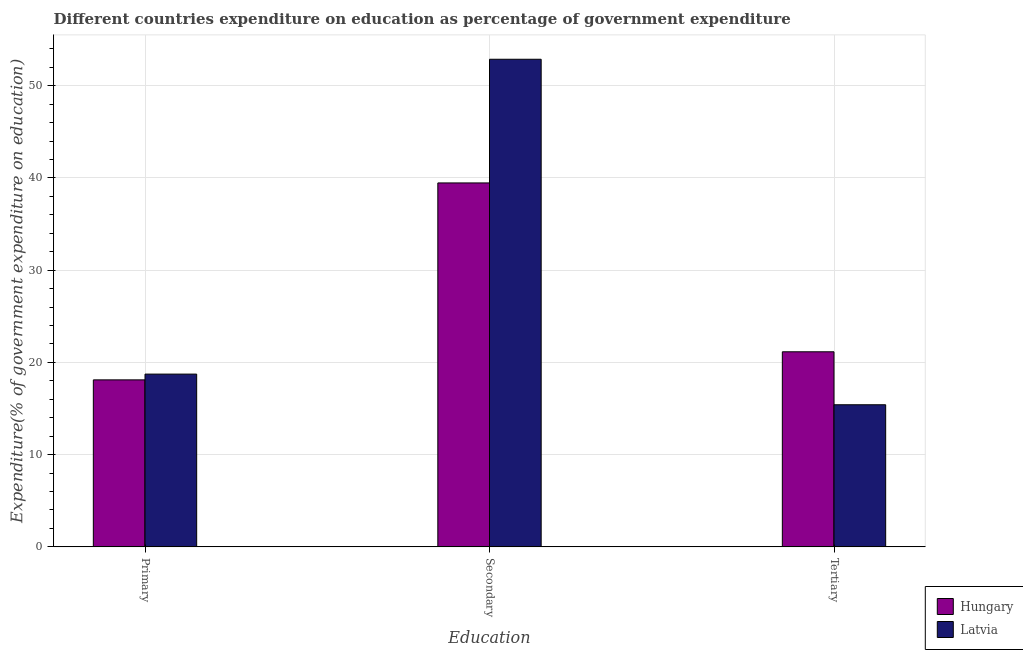Are the number of bars per tick equal to the number of legend labels?
Offer a terse response. Yes. Are the number of bars on each tick of the X-axis equal?
Your response must be concise. Yes. How many bars are there on the 1st tick from the left?
Provide a short and direct response. 2. How many bars are there on the 3rd tick from the right?
Provide a succinct answer. 2. What is the label of the 1st group of bars from the left?
Your answer should be very brief. Primary. What is the expenditure on primary education in Latvia?
Your answer should be very brief. 18.73. Across all countries, what is the maximum expenditure on tertiary education?
Ensure brevity in your answer.  21.15. Across all countries, what is the minimum expenditure on tertiary education?
Ensure brevity in your answer.  15.41. In which country was the expenditure on tertiary education maximum?
Your answer should be compact. Hungary. In which country was the expenditure on primary education minimum?
Make the answer very short. Hungary. What is the total expenditure on secondary education in the graph?
Provide a succinct answer. 92.33. What is the difference between the expenditure on primary education in Latvia and that in Hungary?
Your answer should be compact. 0.62. What is the difference between the expenditure on secondary education in Latvia and the expenditure on primary education in Hungary?
Your response must be concise. 34.76. What is the average expenditure on primary education per country?
Give a very brief answer. 18.42. What is the difference between the expenditure on primary education and expenditure on secondary education in Hungary?
Keep it short and to the point. -21.35. What is the ratio of the expenditure on primary education in Hungary to that in Latvia?
Keep it short and to the point. 0.97. What is the difference between the highest and the second highest expenditure on tertiary education?
Give a very brief answer. 5.74. What is the difference between the highest and the lowest expenditure on secondary education?
Keep it short and to the point. 13.41. What does the 1st bar from the left in Secondary represents?
Offer a terse response. Hungary. What does the 2nd bar from the right in Tertiary represents?
Keep it short and to the point. Hungary. Are all the bars in the graph horizontal?
Make the answer very short. No. Are the values on the major ticks of Y-axis written in scientific E-notation?
Offer a terse response. No. How many legend labels are there?
Provide a succinct answer. 2. How are the legend labels stacked?
Provide a succinct answer. Vertical. What is the title of the graph?
Ensure brevity in your answer.  Different countries expenditure on education as percentage of government expenditure. Does "Nepal" appear as one of the legend labels in the graph?
Your response must be concise. No. What is the label or title of the X-axis?
Your response must be concise. Education. What is the label or title of the Y-axis?
Your answer should be very brief. Expenditure(% of government expenditure on education). What is the Expenditure(% of government expenditure on education) in Hungary in Primary?
Ensure brevity in your answer.  18.11. What is the Expenditure(% of government expenditure on education) in Latvia in Primary?
Provide a succinct answer. 18.73. What is the Expenditure(% of government expenditure on education) in Hungary in Secondary?
Offer a terse response. 39.46. What is the Expenditure(% of government expenditure on education) in Latvia in Secondary?
Provide a succinct answer. 52.87. What is the Expenditure(% of government expenditure on education) of Hungary in Tertiary?
Your answer should be compact. 21.15. What is the Expenditure(% of government expenditure on education) of Latvia in Tertiary?
Provide a succinct answer. 15.41. Across all Education, what is the maximum Expenditure(% of government expenditure on education) of Hungary?
Ensure brevity in your answer.  39.46. Across all Education, what is the maximum Expenditure(% of government expenditure on education) in Latvia?
Keep it short and to the point. 52.87. Across all Education, what is the minimum Expenditure(% of government expenditure on education) of Hungary?
Your answer should be very brief. 18.11. Across all Education, what is the minimum Expenditure(% of government expenditure on education) of Latvia?
Offer a very short reply. 15.41. What is the total Expenditure(% of government expenditure on education) in Hungary in the graph?
Offer a terse response. 78.72. What is the total Expenditure(% of government expenditure on education) of Latvia in the graph?
Provide a short and direct response. 87.01. What is the difference between the Expenditure(% of government expenditure on education) in Hungary in Primary and that in Secondary?
Offer a terse response. -21.35. What is the difference between the Expenditure(% of government expenditure on education) of Latvia in Primary and that in Secondary?
Your answer should be very brief. -34.14. What is the difference between the Expenditure(% of government expenditure on education) of Hungary in Primary and that in Tertiary?
Make the answer very short. -3.04. What is the difference between the Expenditure(% of government expenditure on education) in Latvia in Primary and that in Tertiary?
Make the answer very short. 3.32. What is the difference between the Expenditure(% of government expenditure on education) of Hungary in Secondary and that in Tertiary?
Keep it short and to the point. 18.31. What is the difference between the Expenditure(% of government expenditure on education) of Latvia in Secondary and that in Tertiary?
Provide a short and direct response. 37.46. What is the difference between the Expenditure(% of government expenditure on education) of Hungary in Primary and the Expenditure(% of government expenditure on education) of Latvia in Secondary?
Your response must be concise. -34.76. What is the difference between the Expenditure(% of government expenditure on education) of Hungary in Primary and the Expenditure(% of government expenditure on education) of Latvia in Tertiary?
Offer a terse response. 2.7. What is the difference between the Expenditure(% of government expenditure on education) in Hungary in Secondary and the Expenditure(% of government expenditure on education) in Latvia in Tertiary?
Offer a terse response. 24.05. What is the average Expenditure(% of government expenditure on education) of Hungary per Education?
Give a very brief answer. 26.24. What is the average Expenditure(% of government expenditure on education) of Latvia per Education?
Your response must be concise. 29. What is the difference between the Expenditure(% of government expenditure on education) in Hungary and Expenditure(% of government expenditure on education) in Latvia in Primary?
Provide a succinct answer. -0.62. What is the difference between the Expenditure(% of government expenditure on education) of Hungary and Expenditure(% of government expenditure on education) of Latvia in Secondary?
Offer a very short reply. -13.41. What is the difference between the Expenditure(% of government expenditure on education) of Hungary and Expenditure(% of government expenditure on education) of Latvia in Tertiary?
Offer a terse response. 5.74. What is the ratio of the Expenditure(% of government expenditure on education) of Hungary in Primary to that in Secondary?
Ensure brevity in your answer.  0.46. What is the ratio of the Expenditure(% of government expenditure on education) in Latvia in Primary to that in Secondary?
Provide a short and direct response. 0.35. What is the ratio of the Expenditure(% of government expenditure on education) in Hungary in Primary to that in Tertiary?
Provide a succinct answer. 0.86. What is the ratio of the Expenditure(% of government expenditure on education) of Latvia in Primary to that in Tertiary?
Keep it short and to the point. 1.22. What is the ratio of the Expenditure(% of government expenditure on education) of Hungary in Secondary to that in Tertiary?
Ensure brevity in your answer.  1.87. What is the ratio of the Expenditure(% of government expenditure on education) of Latvia in Secondary to that in Tertiary?
Offer a very short reply. 3.43. What is the difference between the highest and the second highest Expenditure(% of government expenditure on education) of Hungary?
Your answer should be very brief. 18.31. What is the difference between the highest and the second highest Expenditure(% of government expenditure on education) of Latvia?
Offer a terse response. 34.14. What is the difference between the highest and the lowest Expenditure(% of government expenditure on education) in Hungary?
Provide a succinct answer. 21.35. What is the difference between the highest and the lowest Expenditure(% of government expenditure on education) of Latvia?
Give a very brief answer. 37.46. 